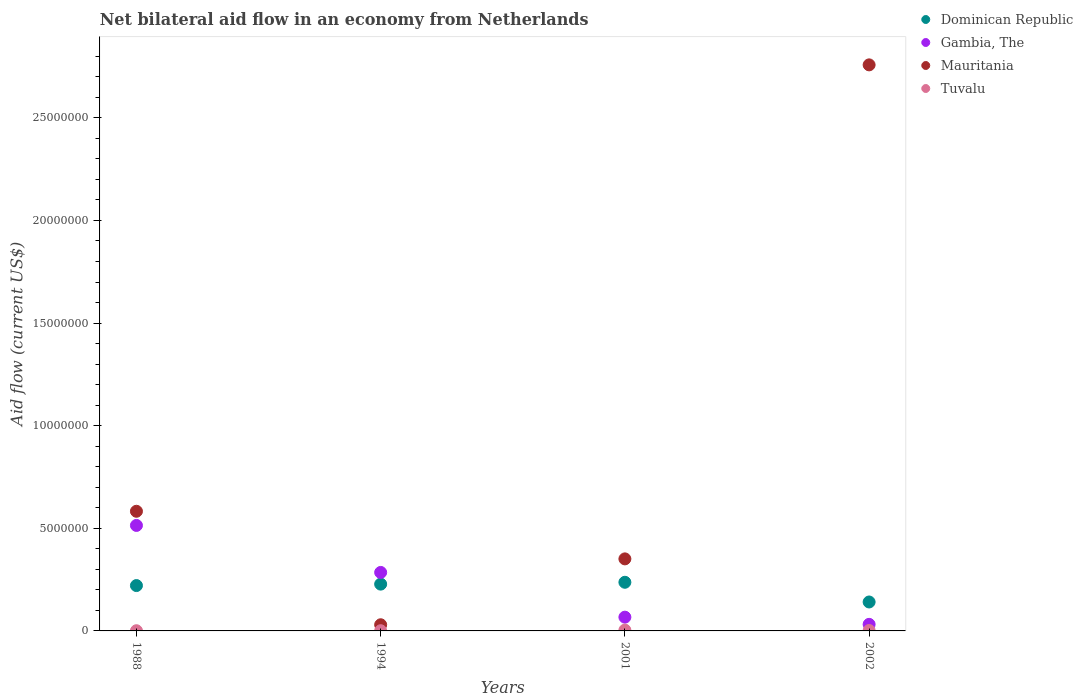Across all years, what is the minimum net bilateral aid flow in Mauritania?
Your answer should be very brief. 3.00e+05. In which year was the net bilateral aid flow in Tuvalu maximum?
Make the answer very short. 2001. In which year was the net bilateral aid flow in Gambia, The minimum?
Your answer should be very brief. 2002. What is the total net bilateral aid flow in Tuvalu in the graph?
Your answer should be very brief. 8.00e+04. What is the difference between the net bilateral aid flow in Gambia, The in 1988 and that in 2002?
Keep it short and to the point. 4.82e+06. What is the difference between the net bilateral aid flow in Tuvalu in 1994 and the net bilateral aid flow in Mauritania in 2001?
Ensure brevity in your answer.  -3.50e+06. In the year 1994, what is the difference between the net bilateral aid flow in Mauritania and net bilateral aid flow in Gambia, The?
Offer a terse response. -2.55e+06. What is the ratio of the net bilateral aid flow in Tuvalu in 1994 to that in 2002?
Ensure brevity in your answer.  0.5. Is the net bilateral aid flow in Mauritania in 1988 less than that in 1994?
Make the answer very short. No. What is the difference between the highest and the second highest net bilateral aid flow in Tuvalu?
Your answer should be very brief. 2.00e+04. What is the difference between the highest and the lowest net bilateral aid flow in Dominican Republic?
Ensure brevity in your answer.  9.60e+05. In how many years, is the net bilateral aid flow in Dominican Republic greater than the average net bilateral aid flow in Dominican Republic taken over all years?
Your response must be concise. 3. Is the sum of the net bilateral aid flow in Mauritania in 2001 and 2002 greater than the maximum net bilateral aid flow in Dominican Republic across all years?
Your response must be concise. Yes. Is it the case that in every year, the sum of the net bilateral aid flow in Gambia, The and net bilateral aid flow in Tuvalu  is greater than the sum of net bilateral aid flow in Dominican Republic and net bilateral aid flow in Mauritania?
Make the answer very short. No. Does the net bilateral aid flow in Dominican Republic monotonically increase over the years?
Your answer should be compact. No. Is the net bilateral aid flow in Gambia, The strictly greater than the net bilateral aid flow in Mauritania over the years?
Offer a very short reply. No. How many dotlines are there?
Your answer should be very brief. 4. What is the difference between two consecutive major ticks on the Y-axis?
Provide a short and direct response. 5.00e+06. Are the values on the major ticks of Y-axis written in scientific E-notation?
Offer a very short reply. No. Where does the legend appear in the graph?
Offer a very short reply. Top right. How many legend labels are there?
Make the answer very short. 4. What is the title of the graph?
Provide a succinct answer. Net bilateral aid flow in an economy from Netherlands. Does "Zambia" appear as one of the legend labels in the graph?
Offer a very short reply. No. What is the label or title of the Y-axis?
Offer a terse response. Aid flow (current US$). What is the Aid flow (current US$) of Dominican Republic in 1988?
Offer a very short reply. 2.21e+06. What is the Aid flow (current US$) in Gambia, The in 1988?
Make the answer very short. 5.14e+06. What is the Aid flow (current US$) of Mauritania in 1988?
Your answer should be very brief. 5.83e+06. What is the Aid flow (current US$) in Tuvalu in 1988?
Ensure brevity in your answer.  10000. What is the Aid flow (current US$) in Dominican Republic in 1994?
Keep it short and to the point. 2.28e+06. What is the Aid flow (current US$) of Gambia, The in 1994?
Ensure brevity in your answer.  2.85e+06. What is the Aid flow (current US$) in Mauritania in 1994?
Provide a short and direct response. 3.00e+05. What is the Aid flow (current US$) of Dominican Republic in 2001?
Ensure brevity in your answer.  2.37e+06. What is the Aid flow (current US$) of Gambia, The in 2001?
Offer a terse response. 6.70e+05. What is the Aid flow (current US$) of Mauritania in 2001?
Make the answer very short. 3.51e+06. What is the Aid flow (current US$) of Dominican Republic in 2002?
Offer a terse response. 1.41e+06. What is the Aid flow (current US$) in Mauritania in 2002?
Your answer should be compact. 2.76e+07. What is the Aid flow (current US$) of Tuvalu in 2002?
Keep it short and to the point. 2.00e+04. Across all years, what is the maximum Aid flow (current US$) of Dominican Republic?
Your answer should be compact. 2.37e+06. Across all years, what is the maximum Aid flow (current US$) of Gambia, The?
Make the answer very short. 5.14e+06. Across all years, what is the maximum Aid flow (current US$) in Mauritania?
Keep it short and to the point. 2.76e+07. Across all years, what is the minimum Aid flow (current US$) of Dominican Republic?
Ensure brevity in your answer.  1.41e+06. Across all years, what is the minimum Aid flow (current US$) of Tuvalu?
Your answer should be very brief. 10000. What is the total Aid flow (current US$) in Dominican Republic in the graph?
Provide a succinct answer. 8.27e+06. What is the total Aid flow (current US$) in Gambia, The in the graph?
Keep it short and to the point. 8.98e+06. What is the total Aid flow (current US$) in Mauritania in the graph?
Keep it short and to the point. 3.72e+07. What is the total Aid flow (current US$) of Tuvalu in the graph?
Provide a succinct answer. 8.00e+04. What is the difference between the Aid flow (current US$) of Gambia, The in 1988 and that in 1994?
Make the answer very short. 2.29e+06. What is the difference between the Aid flow (current US$) in Mauritania in 1988 and that in 1994?
Ensure brevity in your answer.  5.53e+06. What is the difference between the Aid flow (current US$) in Dominican Republic in 1988 and that in 2001?
Provide a succinct answer. -1.60e+05. What is the difference between the Aid flow (current US$) in Gambia, The in 1988 and that in 2001?
Provide a short and direct response. 4.47e+06. What is the difference between the Aid flow (current US$) of Mauritania in 1988 and that in 2001?
Offer a very short reply. 2.32e+06. What is the difference between the Aid flow (current US$) of Dominican Republic in 1988 and that in 2002?
Your answer should be very brief. 8.00e+05. What is the difference between the Aid flow (current US$) in Gambia, The in 1988 and that in 2002?
Ensure brevity in your answer.  4.82e+06. What is the difference between the Aid flow (current US$) of Mauritania in 1988 and that in 2002?
Offer a very short reply. -2.18e+07. What is the difference between the Aid flow (current US$) in Gambia, The in 1994 and that in 2001?
Your response must be concise. 2.18e+06. What is the difference between the Aid flow (current US$) of Mauritania in 1994 and that in 2001?
Make the answer very short. -3.21e+06. What is the difference between the Aid flow (current US$) in Dominican Republic in 1994 and that in 2002?
Provide a succinct answer. 8.70e+05. What is the difference between the Aid flow (current US$) of Gambia, The in 1994 and that in 2002?
Your answer should be very brief. 2.53e+06. What is the difference between the Aid flow (current US$) of Mauritania in 1994 and that in 2002?
Your answer should be very brief. -2.73e+07. What is the difference between the Aid flow (current US$) in Dominican Republic in 2001 and that in 2002?
Offer a very short reply. 9.60e+05. What is the difference between the Aid flow (current US$) in Mauritania in 2001 and that in 2002?
Keep it short and to the point. -2.41e+07. What is the difference between the Aid flow (current US$) of Dominican Republic in 1988 and the Aid flow (current US$) of Gambia, The in 1994?
Keep it short and to the point. -6.40e+05. What is the difference between the Aid flow (current US$) in Dominican Republic in 1988 and the Aid flow (current US$) in Mauritania in 1994?
Your response must be concise. 1.91e+06. What is the difference between the Aid flow (current US$) of Dominican Republic in 1988 and the Aid flow (current US$) of Tuvalu in 1994?
Offer a very short reply. 2.20e+06. What is the difference between the Aid flow (current US$) of Gambia, The in 1988 and the Aid flow (current US$) of Mauritania in 1994?
Your answer should be compact. 4.84e+06. What is the difference between the Aid flow (current US$) of Gambia, The in 1988 and the Aid flow (current US$) of Tuvalu in 1994?
Give a very brief answer. 5.13e+06. What is the difference between the Aid flow (current US$) of Mauritania in 1988 and the Aid flow (current US$) of Tuvalu in 1994?
Your answer should be very brief. 5.82e+06. What is the difference between the Aid flow (current US$) in Dominican Republic in 1988 and the Aid flow (current US$) in Gambia, The in 2001?
Give a very brief answer. 1.54e+06. What is the difference between the Aid flow (current US$) in Dominican Republic in 1988 and the Aid flow (current US$) in Mauritania in 2001?
Your answer should be compact. -1.30e+06. What is the difference between the Aid flow (current US$) of Dominican Republic in 1988 and the Aid flow (current US$) of Tuvalu in 2001?
Offer a terse response. 2.17e+06. What is the difference between the Aid flow (current US$) in Gambia, The in 1988 and the Aid flow (current US$) in Mauritania in 2001?
Your answer should be compact. 1.63e+06. What is the difference between the Aid flow (current US$) in Gambia, The in 1988 and the Aid flow (current US$) in Tuvalu in 2001?
Keep it short and to the point. 5.10e+06. What is the difference between the Aid flow (current US$) of Mauritania in 1988 and the Aid flow (current US$) of Tuvalu in 2001?
Your answer should be compact. 5.79e+06. What is the difference between the Aid flow (current US$) of Dominican Republic in 1988 and the Aid flow (current US$) of Gambia, The in 2002?
Provide a succinct answer. 1.89e+06. What is the difference between the Aid flow (current US$) in Dominican Republic in 1988 and the Aid flow (current US$) in Mauritania in 2002?
Provide a succinct answer. -2.54e+07. What is the difference between the Aid flow (current US$) in Dominican Republic in 1988 and the Aid flow (current US$) in Tuvalu in 2002?
Keep it short and to the point. 2.19e+06. What is the difference between the Aid flow (current US$) of Gambia, The in 1988 and the Aid flow (current US$) of Mauritania in 2002?
Your response must be concise. -2.24e+07. What is the difference between the Aid flow (current US$) in Gambia, The in 1988 and the Aid flow (current US$) in Tuvalu in 2002?
Provide a succinct answer. 5.12e+06. What is the difference between the Aid flow (current US$) of Mauritania in 1988 and the Aid flow (current US$) of Tuvalu in 2002?
Your response must be concise. 5.81e+06. What is the difference between the Aid flow (current US$) in Dominican Republic in 1994 and the Aid flow (current US$) in Gambia, The in 2001?
Provide a succinct answer. 1.61e+06. What is the difference between the Aid flow (current US$) in Dominican Republic in 1994 and the Aid flow (current US$) in Mauritania in 2001?
Keep it short and to the point. -1.23e+06. What is the difference between the Aid flow (current US$) of Dominican Republic in 1994 and the Aid flow (current US$) of Tuvalu in 2001?
Ensure brevity in your answer.  2.24e+06. What is the difference between the Aid flow (current US$) in Gambia, The in 1994 and the Aid flow (current US$) in Mauritania in 2001?
Your answer should be very brief. -6.60e+05. What is the difference between the Aid flow (current US$) of Gambia, The in 1994 and the Aid flow (current US$) of Tuvalu in 2001?
Ensure brevity in your answer.  2.81e+06. What is the difference between the Aid flow (current US$) of Mauritania in 1994 and the Aid flow (current US$) of Tuvalu in 2001?
Your answer should be compact. 2.60e+05. What is the difference between the Aid flow (current US$) in Dominican Republic in 1994 and the Aid flow (current US$) in Gambia, The in 2002?
Give a very brief answer. 1.96e+06. What is the difference between the Aid flow (current US$) in Dominican Republic in 1994 and the Aid flow (current US$) in Mauritania in 2002?
Offer a very short reply. -2.53e+07. What is the difference between the Aid flow (current US$) in Dominican Republic in 1994 and the Aid flow (current US$) in Tuvalu in 2002?
Offer a very short reply. 2.26e+06. What is the difference between the Aid flow (current US$) in Gambia, The in 1994 and the Aid flow (current US$) in Mauritania in 2002?
Make the answer very short. -2.47e+07. What is the difference between the Aid flow (current US$) in Gambia, The in 1994 and the Aid flow (current US$) in Tuvalu in 2002?
Offer a terse response. 2.83e+06. What is the difference between the Aid flow (current US$) in Dominican Republic in 2001 and the Aid flow (current US$) in Gambia, The in 2002?
Make the answer very short. 2.05e+06. What is the difference between the Aid flow (current US$) in Dominican Republic in 2001 and the Aid flow (current US$) in Mauritania in 2002?
Provide a short and direct response. -2.52e+07. What is the difference between the Aid flow (current US$) in Dominican Republic in 2001 and the Aid flow (current US$) in Tuvalu in 2002?
Provide a succinct answer. 2.35e+06. What is the difference between the Aid flow (current US$) of Gambia, The in 2001 and the Aid flow (current US$) of Mauritania in 2002?
Ensure brevity in your answer.  -2.69e+07. What is the difference between the Aid flow (current US$) in Gambia, The in 2001 and the Aid flow (current US$) in Tuvalu in 2002?
Make the answer very short. 6.50e+05. What is the difference between the Aid flow (current US$) of Mauritania in 2001 and the Aid flow (current US$) of Tuvalu in 2002?
Make the answer very short. 3.49e+06. What is the average Aid flow (current US$) of Dominican Republic per year?
Provide a succinct answer. 2.07e+06. What is the average Aid flow (current US$) in Gambia, The per year?
Offer a very short reply. 2.24e+06. What is the average Aid flow (current US$) of Mauritania per year?
Give a very brief answer. 9.30e+06. In the year 1988, what is the difference between the Aid flow (current US$) of Dominican Republic and Aid flow (current US$) of Gambia, The?
Offer a very short reply. -2.93e+06. In the year 1988, what is the difference between the Aid flow (current US$) of Dominican Republic and Aid flow (current US$) of Mauritania?
Give a very brief answer. -3.62e+06. In the year 1988, what is the difference between the Aid flow (current US$) of Dominican Republic and Aid flow (current US$) of Tuvalu?
Ensure brevity in your answer.  2.20e+06. In the year 1988, what is the difference between the Aid flow (current US$) in Gambia, The and Aid flow (current US$) in Mauritania?
Provide a succinct answer. -6.90e+05. In the year 1988, what is the difference between the Aid flow (current US$) in Gambia, The and Aid flow (current US$) in Tuvalu?
Your response must be concise. 5.13e+06. In the year 1988, what is the difference between the Aid flow (current US$) in Mauritania and Aid flow (current US$) in Tuvalu?
Your response must be concise. 5.82e+06. In the year 1994, what is the difference between the Aid flow (current US$) of Dominican Republic and Aid flow (current US$) of Gambia, The?
Your response must be concise. -5.70e+05. In the year 1994, what is the difference between the Aid flow (current US$) in Dominican Republic and Aid flow (current US$) in Mauritania?
Make the answer very short. 1.98e+06. In the year 1994, what is the difference between the Aid flow (current US$) in Dominican Republic and Aid flow (current US$) in Tuvalu?
Ensure brevity in your answer.  2.27e+06. In the year 1994, what is the difference between the Aid flow (current US$) of Gambia, The and Aid flow (current US$) of Mauritania?
Offer a terse response. 2.55e+06. In the year 1994, what is the difference between the Aid flow (current US$) in Gambia, The and Aid flow (current US$) in Tuvalu?
Give a very brief answer. 2.84e+06. In the year 1994, what is the difference between the Aid flow (current US$) in Mauritania and Aid flow (current US$) in Tuvalu?
Make the answer very short. 2.90e+05. In the year 2001, what is the difference between the Aid flow (current US$) of Dominican Republic and Aid flow (current US$) of Gambia, The?
Ensure brevity in your answer.  1.70e+06. In the year 2001, what is the difference between the Aid flow (current US$) in Dominican Republic and Aid flow (current US$) in Mauritania?
Give a very brief answer. -1.14e+06. In the year 2001, what is the difference between the Aid flow (current US$) in Dominican Republic and Aid flow (current US$) in Tuvalu?
Your answer should be very brief. 2.33e+06. In the year 2001, what is the difference between the Aid flow (current US$) in Gambia, The and Aid flow (current US$) in Mauritania?
Your answer should be very brief. -2.84e+06. In the year 2001, what is the difference between the Aid flow (current US$) of Gambia, The and Aid flow (current US$) of Tuvalu?
Ensure brevity in your answer.  6.30e+05. In the year 2001, what is the difference between the Aid flow (current US$) of Mauritania and Aid flow (current US$) of Tuvalu?
Provide a succinct answer. 3.47e+06. In the year 2002, what is the difference between the Aid flow (current US$) of Dominican Republic and Aid flow (current US$) of Gambia, The?
Ensure brevity in your answer.  1.09e+06. In the year 2002, what is the difference between the Aid flow (current US$) in Dominican Republic and Aid flow (current US$) in Mauritania?
Ensure brevity in your answer.  -2.62e+07. In the year 2002, what is the difference between the Aid flow (current US$) of Dominican Republic and Aid flow (current US$) of Tuvalu?
Provide a succinct answer. 1.39e+06. In the year 2002, what is the difference between the Aid flow (current US$) of Gambia, The and Aid flow (current US$) of Mauritania?
Provide a short and direct response. -2.73e+07. In the year 2002, what is the difference between the Aid flow (current US$) of Mauritania and Aid flow (current US$) of Tuvalu?
Your answer should be compact. 2.76e+07. What is the ratio of the Aid flow (current US$) in Dominican Republic in 1988 to that in 1994?
Your answer should be compact. 0.97. What is the ratio of the Aid flow (current US$) of Gambia, The in 1988 to that in 1994?
Your answer should be very brief. 1.8. What is the ratio of the Aid flow (current US$) of Mauritania in 1988 to that in 1994?
Make the answer very short. 19.43. What is the ratio of the Aid flow (current US$) in Dominican Republic in 1988 to that in 2001?
Your answer should be compact. 0.93. What is the ratio of the Aid flow (current US$) of Gambia, The in 1988 to that in 2001?
Keep it short and to the point. 7.67. What is the ratio of the Aid flow (current US$) of Mauritania in 1988 to that in 2001?
Make the answer very short. 1.66. What is the ratio of the Aid flow (current US$) in Dominican Republic in 1988 to that in 2002?
Your answer should be very brief. 1.57. What is the ratio of the Aid flow (current US$) of Gambia, The in 1988 to that in 2002?
Make the answer very short. 16.06. What is the ratio of the Aid flow (current US$) of Mauritania in 1988 to that in 2002?
Your response must be concise. 0.21. What is the ratio of the Aid flow (current US$) in Tuvalu in 1988 to that in 2002?
Keep it short and to the point. 0.5. What is the ratio of the Aid flow (current US$) in Dominican Republic in 1994 to that in 2001?
Offer a very short reply. 0.96. What is the ratio of the Aid flow (current US$) of Gambia, The in 1994 to that in 2001?
Your answer should be very brief. 4.25. What is the ratio of the Aid flow (current US$) in Mauritania in 1994 to that in 2001?
Make the answer very short. 0.09. What is the ratio of the Aid flow (current US$) of Tuvalu in 1994 to that in 2001?
Your answer should be very brief. 0.25. What is the ratio of the Aid flow (current US$) of Dominican Republic in 1994 to that in 2002?
Keep it short and to the point. 1.62. What is the ratio of the Aid flow (current US$) of Gambia, The in 1994 to that in 2002?
Ensure brevity in your answer.  8.91. What is the ratio of the Aid flow (current US$) of Mauritania in 1994 to that in 2002?
Your response must be concise. 0.01. What is the ratio of the Aid flow (current US$) in Dominican Republic in 2001 to that in 2002?
Offer a very short reply. 1.68. What is the ratio of the Aid flow (current US$) in Gambia, The in 2001 to that in 2002?
Give a very brief answer. 2.09. What is the ratio of the Aid flow (current US$) of Mauritania in 2001 to that in 2002?
Your response must be concise. 0.13. What is the difference between the highest and the second highest Aid flow (current US$) of Gambia, The?
Ensure brevity in your answer.  2.29e+06. What is the difference between the highest and the second highest Aid flow (current US$) in Mauritania?
Give a very brief answer. 2.18e+07. What is the difference between the highest and the second highest Aid flow (current US$) of Tuvalu?
Give a very brief answer. 2.00e+04. What is the difference between the highest and the lowest Aid flow (current US$) of Dominican Republic?
Your response must be concise. 9.60e+05. What is the difference between the highest and the lowest Aid flow (current US$) in Gambia, The?
Offer a very short reply. 4.82e+06. What is the difference between the highest and the lowest Aid flow (current US$) in Mauritania?
Provide a short and direct response. 2.73e+07. 